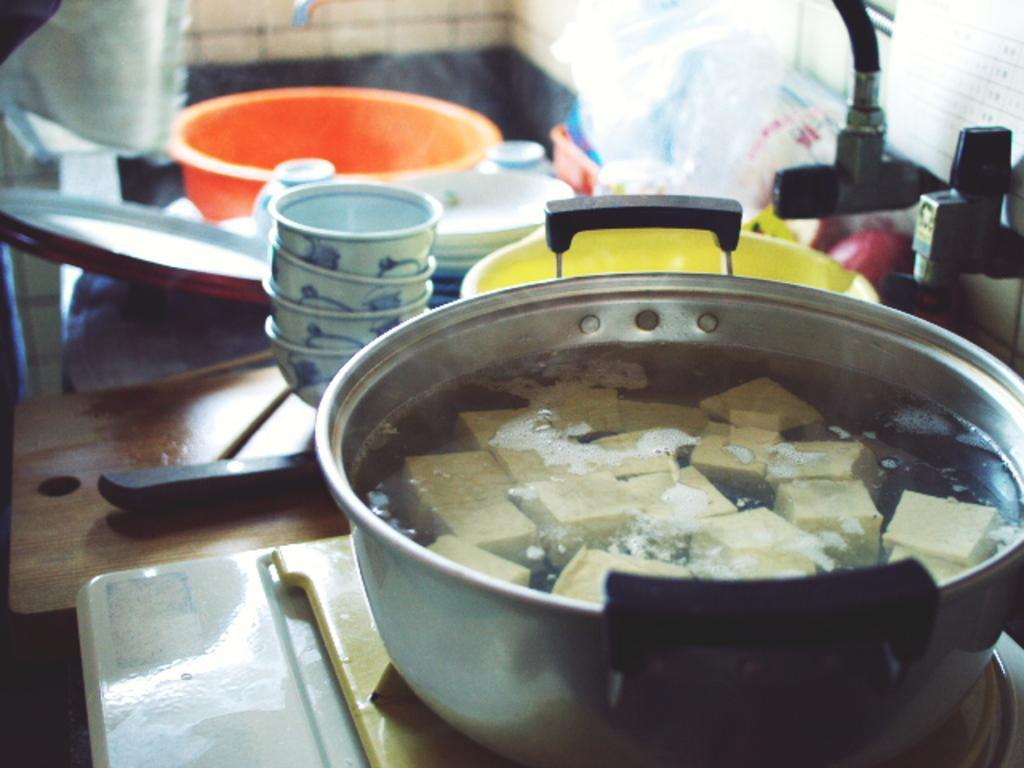Can you describe this image briefly? In this picture I can see a food item in the cooking vessel, which is on the stove. I can see bowls, plates, chop board and some other objects. 